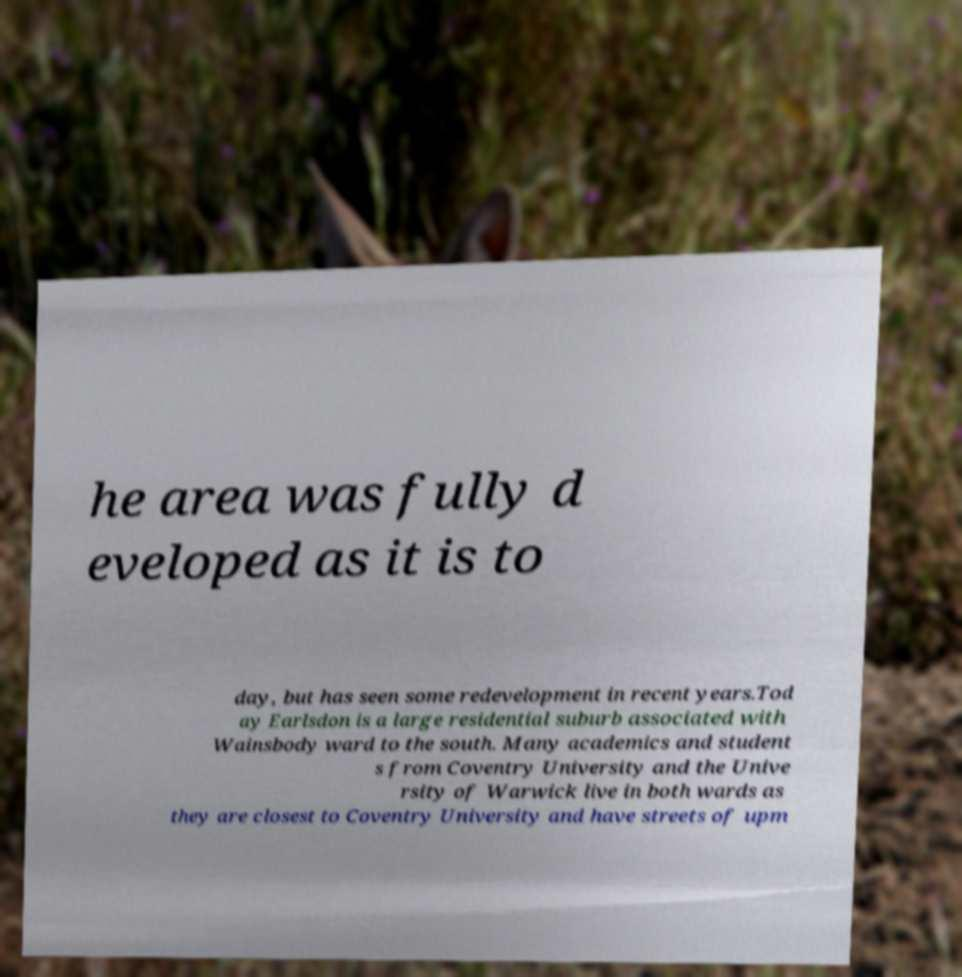Please read and relay the text visible in this image. What does it say? he area was fully d eveloped as it is to day, but has seen some redevelopment in recent years.Tod ay Earlsdon is a large residential suburb associated with Wainsbody ward to the south. Many academics and student s from Coventry University and the Unive rsity of Warwick live in both wards as they are closest to Coventry University and have streets of upm 